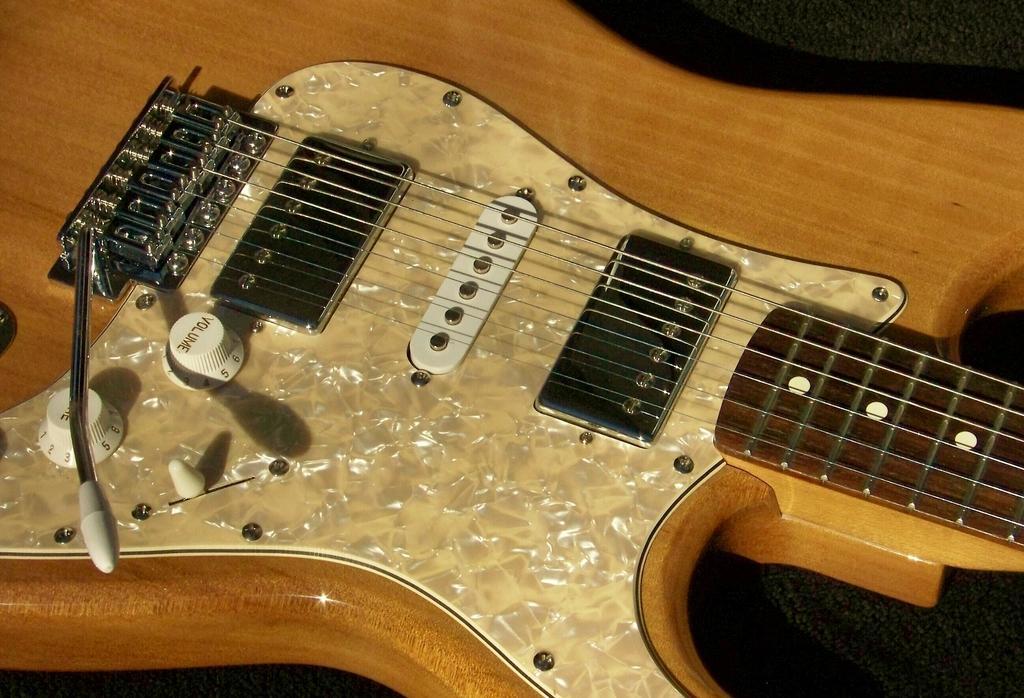Please provide a concise description of this image. In this image there is a guitar made up of wood. On the guitar there are strings and white knobs for increasing volume. 